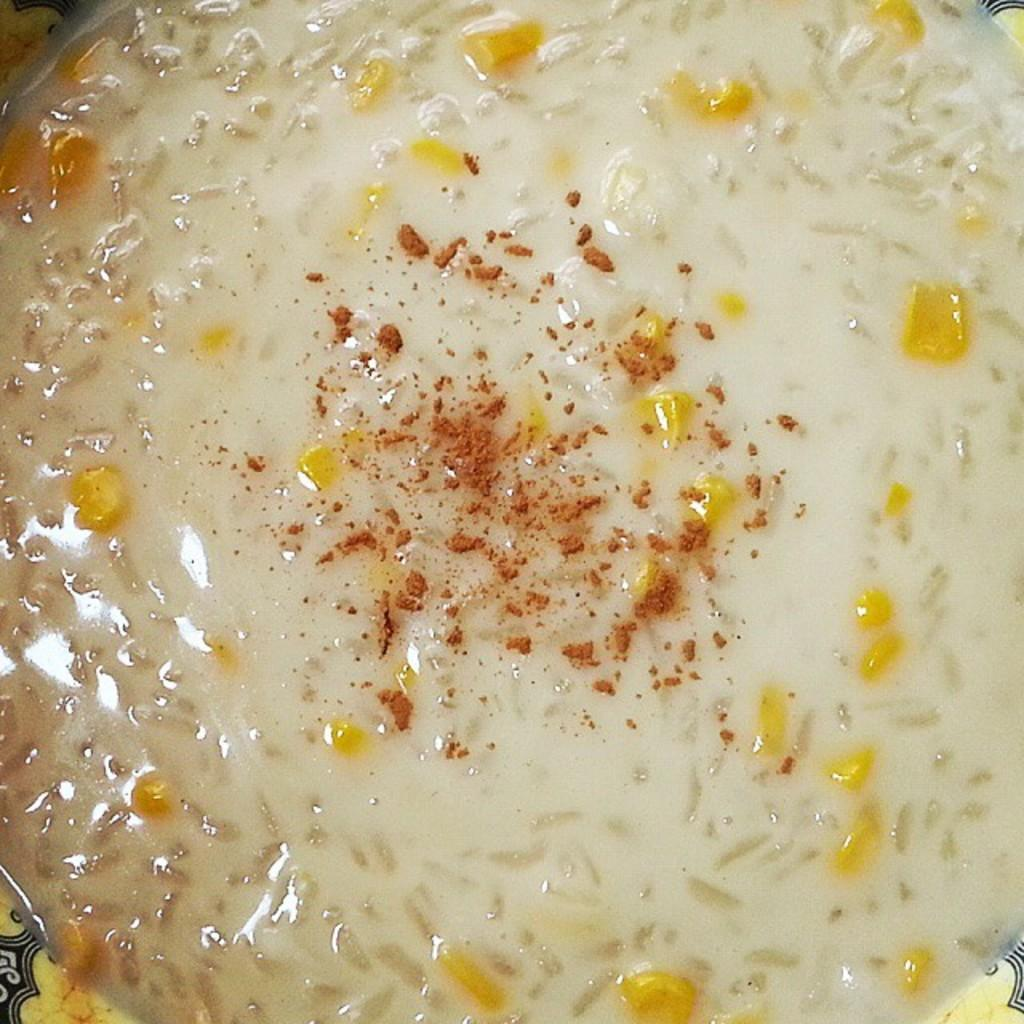What is the main subject of the image? There is a food item in the image. Can you describe the object that contains the food item? The food item is in an object. How many icicles are hanging from the food item in the image? There are no icicles present in the image. 